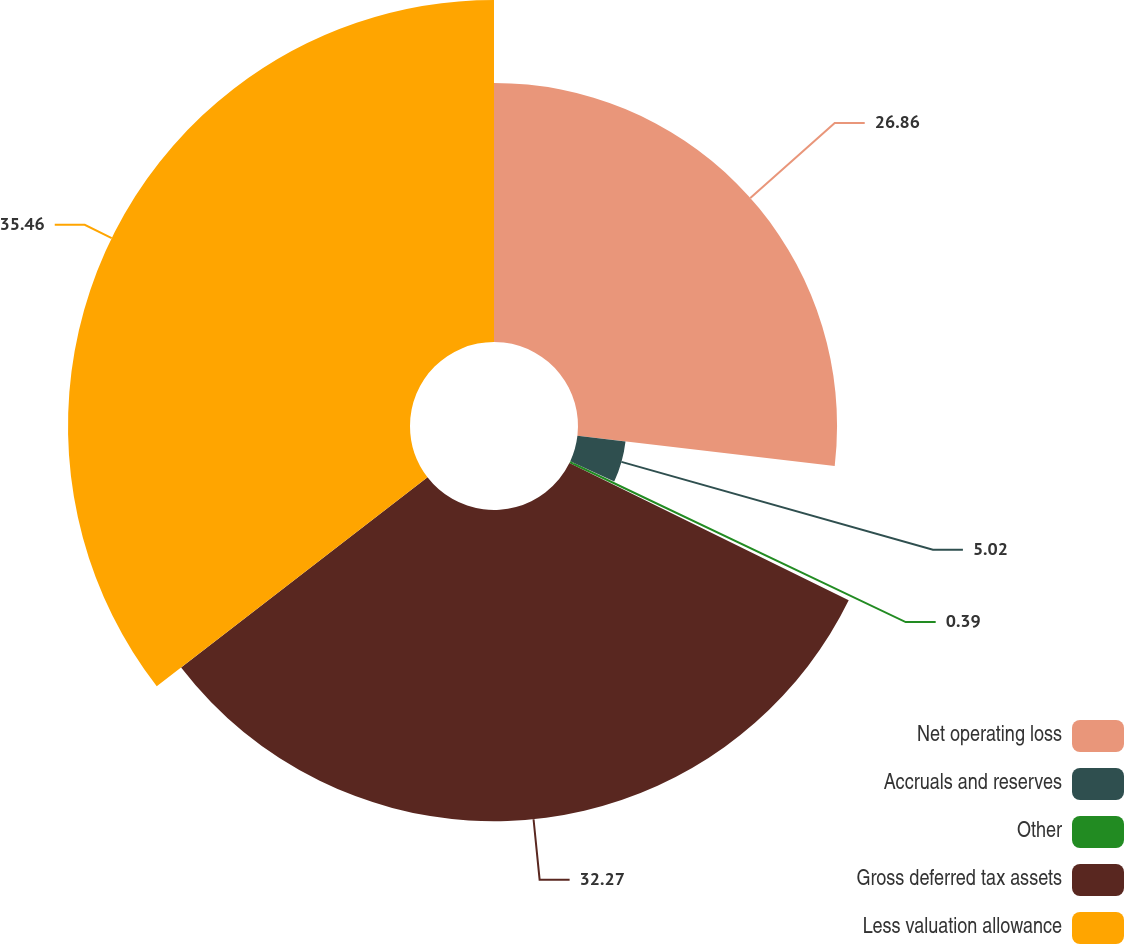Convert chart. <chart><loc_0><loc_0><loc_500><loc_500><pie_chart><fcel>Net operating loss<fcel>Accruals and reserves<fcel>Other<fcel>Gross deferred tax assets<fcel>Less valuation allowance<nl><fcel>26.86%<fcel>5.02%<fcel>0.39%<fcel>32.27%<fcel>35.46%<nl></chart> 